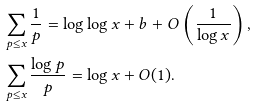<formula> <loc_0><loc_0><loc_500><loc_500>& \sum _ { p \leq x } \frac { 1 } { p } = \log \log x + b + O \left ( \frac { 1 } { \log x } \right ) , \\ & \sum _ { p \leq x } \frac { \log p } { p } = \log x + O ( 1 ) .</formula> 